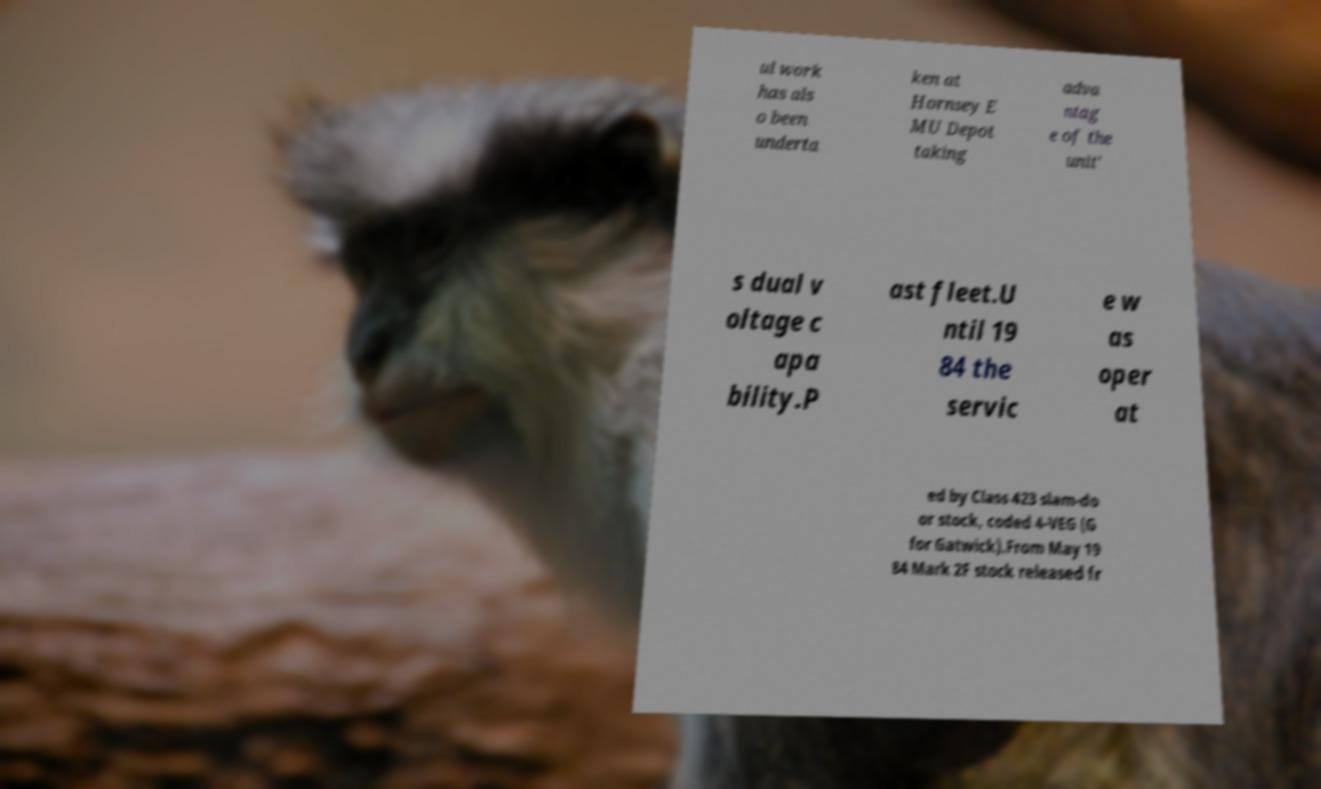For documentation purposes, I need the text within this image transcribed. Could you provide that? ul work has als o been underta ken at Hornsey E MU Depot taking adva ntag e of the unit' s dual v oltage c apa bility.P ast fleet.U ntil 19 84 the servic e w as oper at ed by Class 423 slam-do or stock, coded 4-VEG (G for Gatwick).From May 19 84 Mark 2F stock released fr 